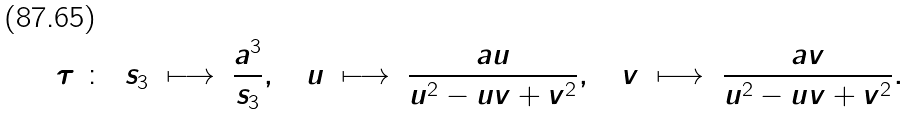Convert formula to latex. <formula><loc_0><loc_0><loc_500><loc_500>\tau \ \colon \ & \ s _ { 3 } \ \longmapsto \ \frac { a ^ { 3 } } { s _ { 3 } } , \quad u \ \longmapsto \ \frac { a u } { u ^ { 2 } - u v + v ^ { 2 } } , \quad v \ \longmapsto \ \frac { a v } { u ^ { 2 } - u v + v ^ { 2 } } .</formula> 